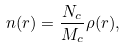<formula> <loc_0><loc_0><loc_500><loc_500>n ( r ) = \frac { N _ { c } } { M _ { c } } \rho ( r ) ,</formula> 